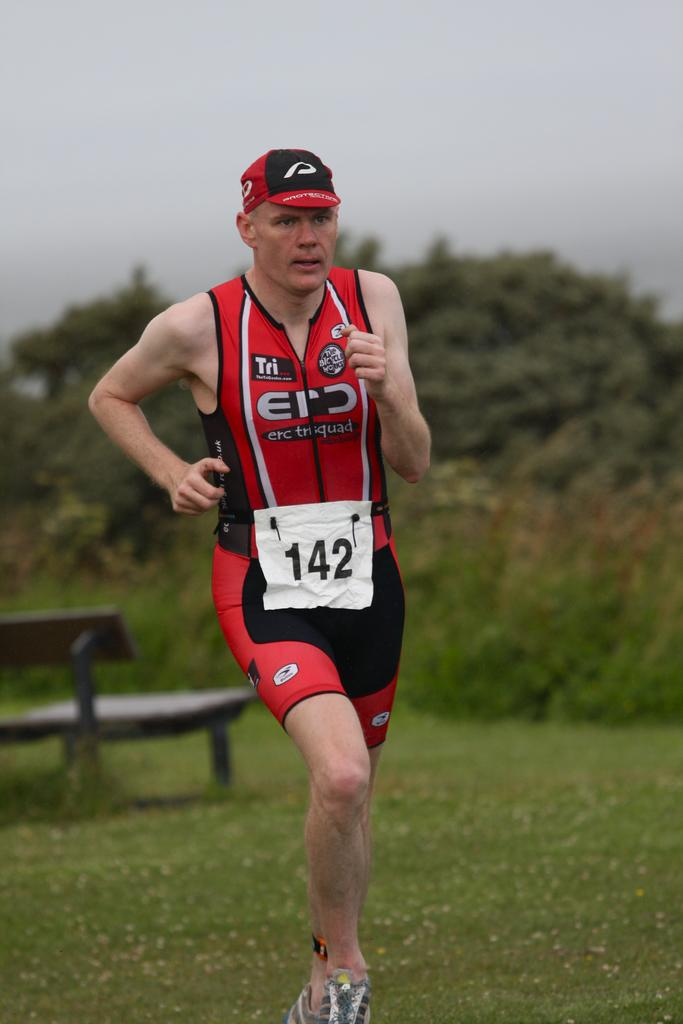<image>
Offer a succinct explanation of the picture presented. A man is wearing the number 142 while running. 